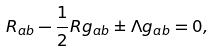Convert formula to latex. <formula><loc_0><loc_0><loc_500><loc_500>R _ { a b } - \frac { 1 } { 2 } R g _ { a b } \pm \Lambda g _ { a b } = 0 ,</formula> 